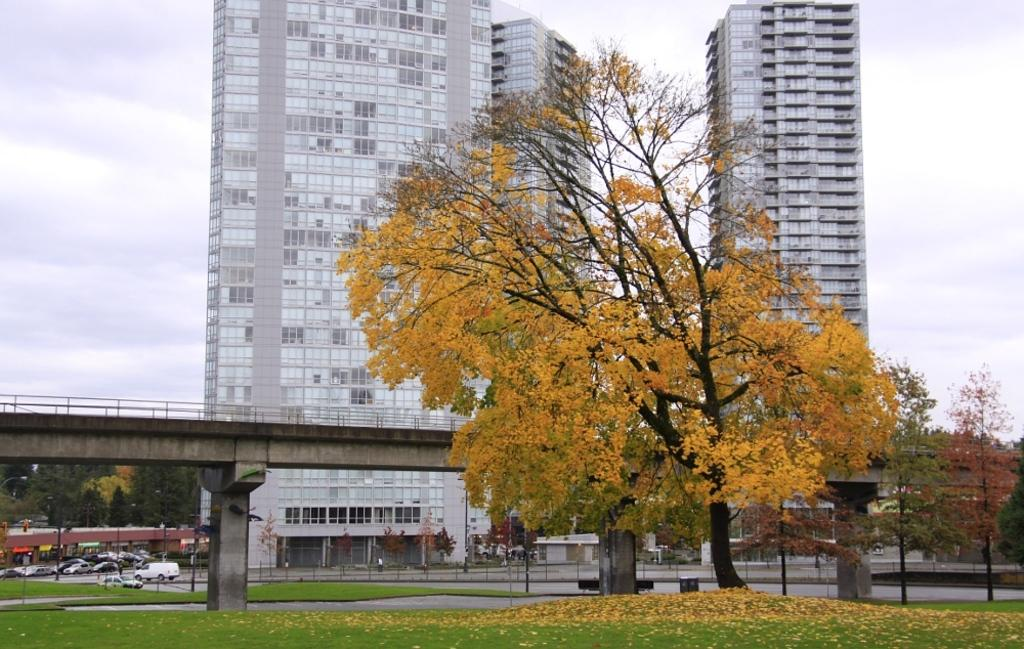What type of structures can be seen in the image? There are buildings in the image. Where are the cars located in the image? The cars are parked on the left side of the image. What is the purpose of the structure in the middle of the image? There is a bridge in the image, which is used for crossing over bodies of water or other obstacles. What type of vegetation is present in the image? There are trees in the image. What is the ground covered with in the image? The ground is covered with grass in the image. What is the condition of the sky in the image? The sky is cloudy in the image. Can you see the eye of the volcano in the image? There is no volcano present in the image, so it is not possible to see the eye of a volcano. 